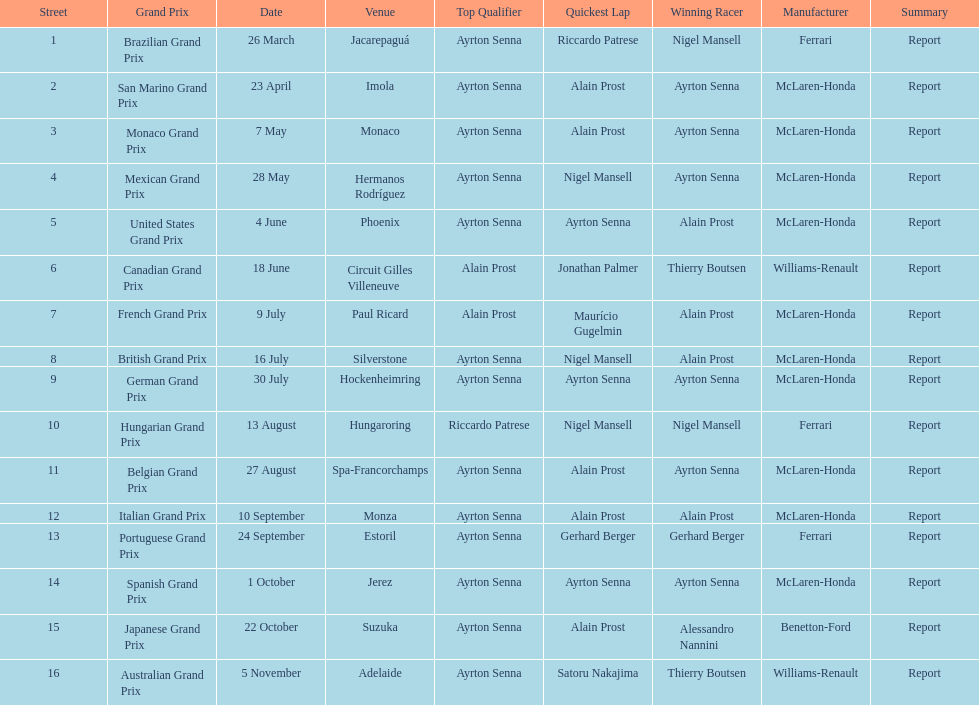What was the grand prix event that occurred before the san marino one? Brazilian Grand Prix. 